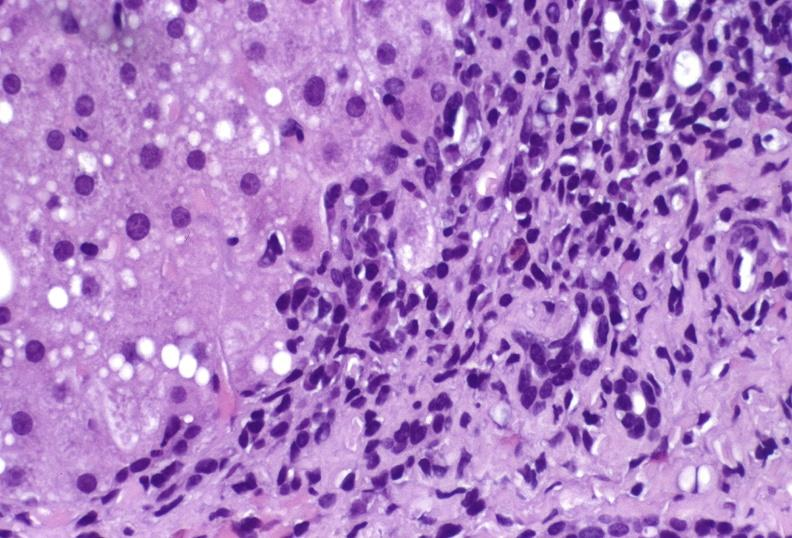s hepatobiliary present?
Answer the question using a single word or phrase. Yes 